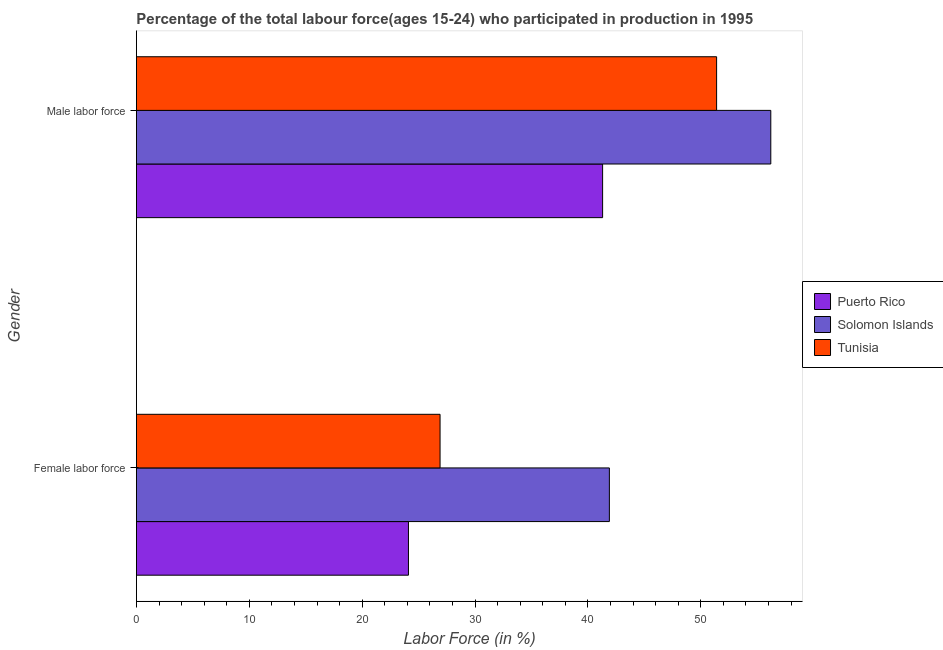How many different coloured bars are there?
Provide a short and direct response. 3. How many groups of bars are there?
Your response must be concise. 2. Are the number of bars per tick equal to the number of legend labels?
Ensure brevity in your answer.  Yes. How many bars are there on the 1st tick from the top?
Give a very brief answer. 3. What is the label of the 2nd group of bars from the top?
Keep it short and to the point. Female labor force. What is the percentage of male labour force in Puerto Rico?
Provide a succinct answer. 41.3. Across all countries, what is the maximum percentage of female labor force?
Make the answer very short. 41.9. Across all countries, what is the minimum percentage of male labour force?
Your answer should be very brief. 41.3. In which country was the percentage of female labor force maximum?
Give a very brief answer. Solomon Islands. In which country was the percentage of male labour force minimum?
Offer a terse response. Puerto Rico. What is the total percentage of male labour force in the graph?
Your response must be concise. 148.9. What is the difference between the percentage of male labour force in Solomon Islands and that in Tunisia?
Ensure brevity in your answer.  4.8. What is the difference between the percentage of female labor force in Solomon Islands and the percentage of male labour force in Puerto Rico?
Your response must be concise. 0.6. What is the average percentage of male labour force per country?
Make the answer very short. 49.63. What is the difference between the percentage of female labor force and percentage of male labour force in Puerto Rico?
Your response must be concise. -17.2. In how many countries, is the percentage of female labor force greater than 16 %?
Offer a terse response. 3. What is the ratio of the percentage of male labour force in Tunisia to that in Solomon Islands?
Your response must be concise. 0.91. What does the 1st bar from the top in Male labor force represents?
Your answer should be compact. Tunisia. What does the 2nd bar from the bottom in Female labor force represents?
Offer a terse response. Solomon Islands. How many countries are there in the graph?
Your response must be concise. 3. Does the graph contain any zero values?
Provide a short and direct response. No. How many legend labels are there?
Your answer should be compact. 3. What is the title of the graph?
Your answer should be very brief. Percentage of the total labour force(ages 15-24) who participated in production in 1995. What is the label or title of the X-axis?
Provide a succinct answer. Labor Force (in %). What is the Labor Force (in %) in Puerto Rico in Female labor force?
Keep it short and to the point. 24.1. What is the Labor Force (in %) of Solomon Islands in Female labor force?
Provide a succinct answer. 41.9. What is the Labor Force (in %) in Tunisia in Female labor force?
Provide a succinct answer. 26.9. What is the Labor Force (in %) of Puerto Rico in Male labor force?
Your answer should be very brief. 41.3. What is the Labor Force (in %) in Solomon Islands in Male labor force?
Provide a short and direct response. 56.2. What is the Labor Force (in %) in Tunisia in Male labor force?
Keep it short and to the point. 51.4. Across all Gender, what is the maximum Labor Force (in %) of Puerto Rico?
Your response must be concise. 41.3. Across all Gender, what is the maximum Labor Force (in %) in Solomon Islands?
Make the answer very short. 56.2. Across all Gender, what is the maximum Labor Force (in %) in Tunisia?
Provide a short and direct response. 51.4. Across all Gender, what is the minimum Labor Force (in %) in Puerto Rico?
Make the answer very short. 24.1. Across all Gender, what is the minimum Labor Force (in %) of Solomon Islands?
Ensure brevity in your answer.  41.9. Across all Gender, what is the minimum Labor Force (in %) in Tunisia?
Your answer should be very brief. 26.9. What is the total Labor Force (in %) of Puerto Rico in the graph?
Keep it short and to the point. 65.4. What is the total Labor Force (in %) of Solomon Islands in the graph?
Your answer should be compact. 98.1. What is the total Labor Force (in %) of Tunisia in the graph?
Ensure brevity in your answer.  78.3. What is the difference between the Labor Force (in %) of Puerto Rico in Female labor force and that in Male labor force?
Offer a terse response. -17.2. What is the difference between the Labor Force (in %) in Solomon Islands in Female labor force and that in Male labor force?
Keep it short and to the point. -14.3. What is the difference between the Labor Force (in %) of Tunisia in Female labor force and that in Male labor force?
Provide a short and direct response. -24.5. What is the difference between the Labor Force (in %) in Puerto Rico in Female labor force and the Labor Force (in %) in Solomon Islands in Male labor force?
Give a very brief answer. -32.1. What is the difference between the Labor Force (in %) of Puerto Rico in Female labor force and the Labor Force (in %) of Tunisia in Male labor force?
Offer a very short reply. -27.3. What is the average Labor Force (in %) of Puerto Rico per Gender?
Provide a succinct answer. 32.7. What is the average Labor Force (in %) in Solomon Islands per Gender?
Keep it short and to the point. 49.05. What is the average Labor Force (in %) in Tunisia per Gender?
Keep it short and to the point. 39.15. What is the difference between the Labor Force (in %) in Puerto Rico and Labor Force (in %) in Solomon Islands in Female labor force?
Make the answer very short. -17.8. What is the difference between the Labor Force (in %) in Solomon Islands and Labor Force (in %) in Tunisia in Female labor force?
Provide a short and direct response. 15. What is the difference between the Labor Force (in %) of Puerto Rico and Labor Force (in %) of Solomon Islands in Male labor force?
Provide a succinct answer. -14.9. What is the difference between the Labor Force (in %) in Puerto Rico and Labor Force (in %) in Tunisia in Male labor force?
Your answer should be very brief. -10.1. What is the ratio of the Labor Force (in %) of Puerto Rico in Female labor force to that in Male labor force?
Your response must be concise. 0.58. What is the ratio of the Labor Force (in %) in Solomon Islands in Female labor force to that in Male labor force?
Your response must be concise. 0.75. What is the ratio of the Labor Force (in %) of Tunisia in Female labor force to that in Male labor force?
Your answer should be very brief. 0.52. What is the difference between the highest and the second highest Labor Force (in %) in Tunisia?
Offer a terse response. 24.5. What is the difference between the highest and the lowest Labor Force (in %) of Puerto Rico?
Your response must be concise. 17.2. 